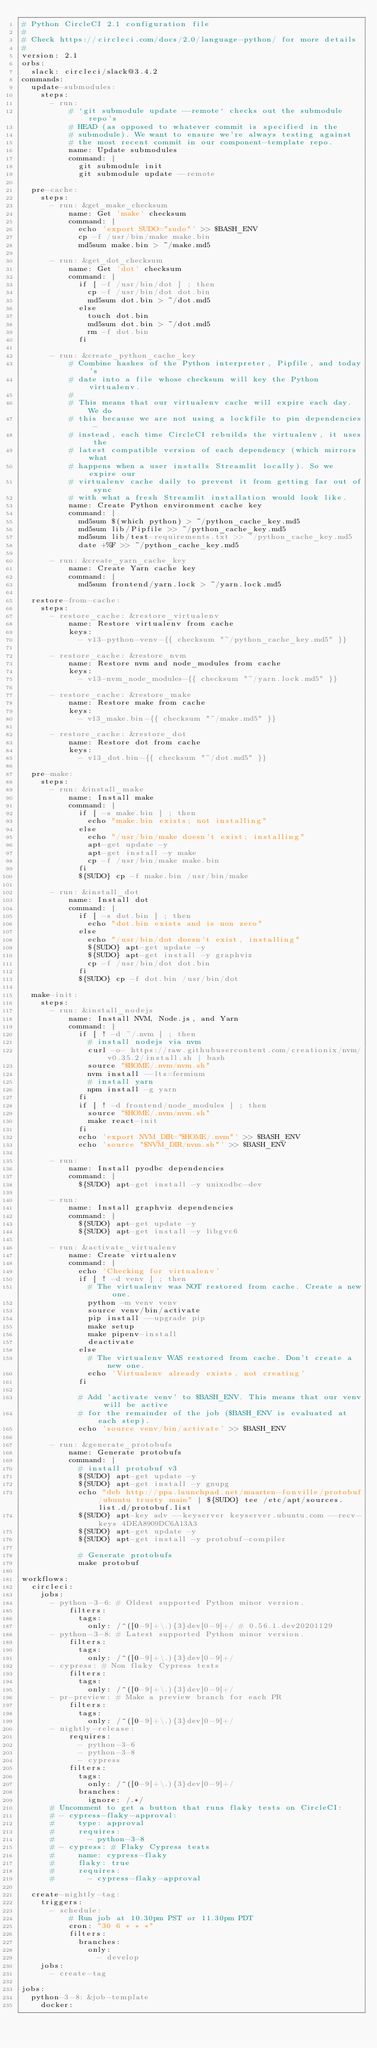<code> <loc_0><loc_0><loc_500><loc_500><_YAML_># Python CircleCI 2.1 configuration file
#
# Check https://circleci.com/docs/2.0/language-python/ for more details
#
version: 2.1
orbs:
  slack: circleci/slack@3.4.2
commands:
  update-submodules:
    steps:
      - run:
          # `git submodule update --remote` checks out the submodule repo's
          # HEAD (as opposed to whatever commit is specified in the
          # submodule). We want to ensure we're always testing against
          # the most recent commit in our component-template repo.
          name: Update submodules
          command: |
            git submodule init
            git submodule update --remote

  pre-cache:
    steps:
      - run: &get_make_checksum
          name: Get 'make' checksum
          command: |
            echo 'export SUDO="sudo"' >> $BASH_ENV
            cp -f /usr/bin/make make.bin
            md5sum make.bin > ~/make.md5

      - run: &get_dot_checksum
          name: Get 'dot' checksum
          command: |
            if [ -f /usr/bin/dot ] ; then
              cp -f /usr/bin/dot dot.bin
              md5sum dot.bin > ~/dot.md5
            else
              touch dot.bin
              md5sum dot.bin > ~/dot.md5
              rm -f dot.bin
            fi

      - run: &create_python_cache_key
          # Combine hashes of the Python interpreter, Pipfile, and today's
          # date into a file whose checksum will key the Python virtualenv.
          #
          # This means that our virtualenv cache will expire each day. We do
          # this because we are not using a lockfile to pin dependencies -
          # instead, each time CircleCI rebuilds the virtualenv, it uses the
          # latest compatible version of each dependency (which mirrors what
          # happens when a user installs Streamlit locally). So we expire our
          # virtualenv cache daily to prevent it from getting far out of sync
          # with what a fresh Streamlit installation would look like.
          name: Create Python environment cache key
          command: |
            md5sum $(which python) > ~/python_cache_key.md5
            md5sum lib/Pipfile >> ~/python_cache_key.md5
            md5sum lib/test-requirements.txt >> ~/python_cache_key.md5
            date +%F >> ~/python_cache_key.md5

      - run: &create_yarn_cache_key
          name: Create Yarn cache key
          command: |
            md5sum frontend/yarn.lock > ~/yarn.lock.md5

  restore-from-cache:
    steps:
      - restore_cache: &restore_virtualenv
          name: Restore virtualenv from cache
          keys:
            - v13-python-venv-{{ checksum "~/python_cache_key.md5" }}

      - restore_cache: &restore_nvm
          name: Restore nvm and node_modules from cache
          keys:
            - v13-nvm_node_modules-{{ checksum "~/yarn.lock.md5" }}

      - restore_cache: &restore_make
          name: Restore make from cache
          keys:
            - v13_make.bin-{{ checksum "~/make.md5" }}

      - restore_cache: &restore_dot
          name: Restore dot from cache
          keys:
            - v13_dot.bin-{{ checksum "~/dot.md5" }}

  pre-make:
    steps:
      - run: &install_make
          name: Install make
          command: |
            if [ -s make.bin ] ; then
              echo "make.bin exists; not installing"
            else
              echo "/usr/bin/make doesn't exist; installing"
              apt-get update -y
              apt-get install -y make
              cp -f /usr/bin/make make.bin
            fi
            ${SUDO} cp -f make.bin /usr/bin/make

      - run: &install_dot
          name: Install dot
          command: |
            if [ -s dot.bin ] ; then
              echo "dot.bin exists and is non zero"
            else
              echo "/usr/bin/dot doesn't exist, installing"
              ${SUDO} apt-get update -y
              ${SUDO} apt-get install -y graphviz
              cp -f /usr/bin/dot dot.bin
            fi
            ${SUDO} cp -f dot.bin /usr/bin/dot

  make-init:
    steps:
      - run: &install_nodejs
          name: Install NVM, Node.js, and Yarn
          command: |
            if [ ! -d ~/.nvm ] ; then
              # install nodejs via nvm
              curl -o- https://raw.githubusercontent.com/creationix/nvm/v0.35.2/install.sh | bash
              source "$HOME/.nvm/nvm.sh"
              nvm install --lts=fermium
              # install yarn
              npm install -g yarn
            fi
            if [ ! -d frontend/node_modules ] ; then
              source "$HOME/.nvm/nvm.sh"
              make react-init
            fi
            echo 'export NVM_DIR="$HOME/.nvm"' >> $BASH_ENV
            echo 'source "$NVM_DIR/nvm.sh"' >> $BASH_ENV

      - run:
          name: Install pyodbc dependencies
          command: |
            ${SUDO} apt-get install -y unixodbc-dev

      - run:
          name: Install graphviz dependencies
          command: |
            ${SUDO} apt-get update -y
            ${SUDO} apt-get install -y libgvc6

      - run: &activate_virtualenv
          name: Create virtualenv
          command: |
            echo 'Checking for virtualenv'
            if [ ! -d venv ] ; then
              # The virtualenv was NOT restored from cache. Create a new one.
              python -m venv venv
              source venv/bin/activate
              pip install --upgrade pip
              make setup
              make pipenv-install
              deactivate
            else
              # The virtualenv WAS restored from cache. Don't create a new one.
              echo 'Virtualenv already exists, not creating'
            fi

            # Add 'activate venv' to $BASH_ENV. This means that our venv will be active
            # for the remainder of the job ($BASH_ENV is evaluated at each step).
            echo 'source venv/bin/activate' >> $BASH_ENV

      - run: &generate_protobufs
          name: Generate protobufs
          command: |
            # install protobuf v3
            ${SUDO} apt-get update -y
            ${SUDO} apt-get install -y gnupg
            echo "deb http://ppa.launchpad.net/maarten-fonville/protobuf/ubuntu trusty main" | ${SUDO} tee /etc/apt/sources.list.d/protobuf.list
            ${SUDO} apt-key adv --keyserver keyserver.ubuntu.com --recv-keys 4DEA8909DC6A13A3
            ${SUDO} apt-get update -y
            ${SUDO} apt-get install -y protobuf-compiler

            # Generate protobufs
            make protobuf

workflows:
  circleci:
    jobs:
      - python-3-6: # Oldest supported Python minor version.
          filters:
            tags:
              only: /^([0-9]+\.){3}dev[0-9]+/ # 0.56.1.dev20201129
      - python-3-8: # Latest supported Python minor version.
          filters:
            tags:
              only: /^([0-9]+\.){3}dev[0-9]+/
      - cypress: # Non flaky Cypress tests
          filters:
            tags:
              only: /^([0-9]+\.){3}dev[0-9]+/
      - pr-preview: # Make a preview branch for each PR
          filters:
            tags:
              only: /^([0-9]+\.){3}dev[0-9]+/
      - nightly-release:
          requires:
            - python-3-6
            - python-3-8
            - cypress
          filters:
            tags:
              only: /^([0-9]+\.){3}dev[0-9]+/
            branches:
              ignore: /.*/
      # Uncomment to get a button that runs flaky tests on CircleCI:
      # - cypress-flaky-approval:
      #     type: approval
      #     requires:
      #       - python-3-8
      # - cypress: # Flaky Cypress tests
      #     name: cypress-flaky
      #     flaky: true
      #     requires:
      #       - cypress-flaky-approval

  create-nightly-tag:
    triggers:
      - schedule:
          # Run job at 10.30pm PST or 11.30pm PDT
          cron: "30 6 * * *"
          filters:
            branches:
              only:
                - develop
    jobs:
      - create-tag

jobs:
  python-3-8: &job-template
    docker:</code> 